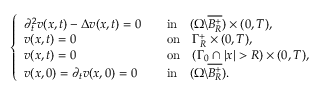<formula> <loc_0><loc_0><loc_500><loc_500>\begin{array} { r } { \left \{ \begin{array} { l l l } { \partial _ { t } ^ { 2 } v ( x , t ) - \Delta v ( x , t ) = 0 } & & { i n \quad ( \Omega \ \overline { { B _ { R } ^ { + } } } ) \times ( 0 , T ) , } \\ { v ( x , t ) = 0 \quad } & & { o n \quad \Gamma _ { R } ^ { + } \times ( 0 , T ) , } \\ { v ( x , t ) = 0 \quad } & & { o n \quad ( \Gamma _ { 0 } \cap | x | > R ) \times ( 0 , T ) , } \\ { v ( x , 0 ) = \partial _ { t } v ( x , 0 ) = 0 } & & { i n \quad ( \Omega \ \overline { { B _ { R } ^ { + } } } ) . } \end{array} } \end{array}</formula> 